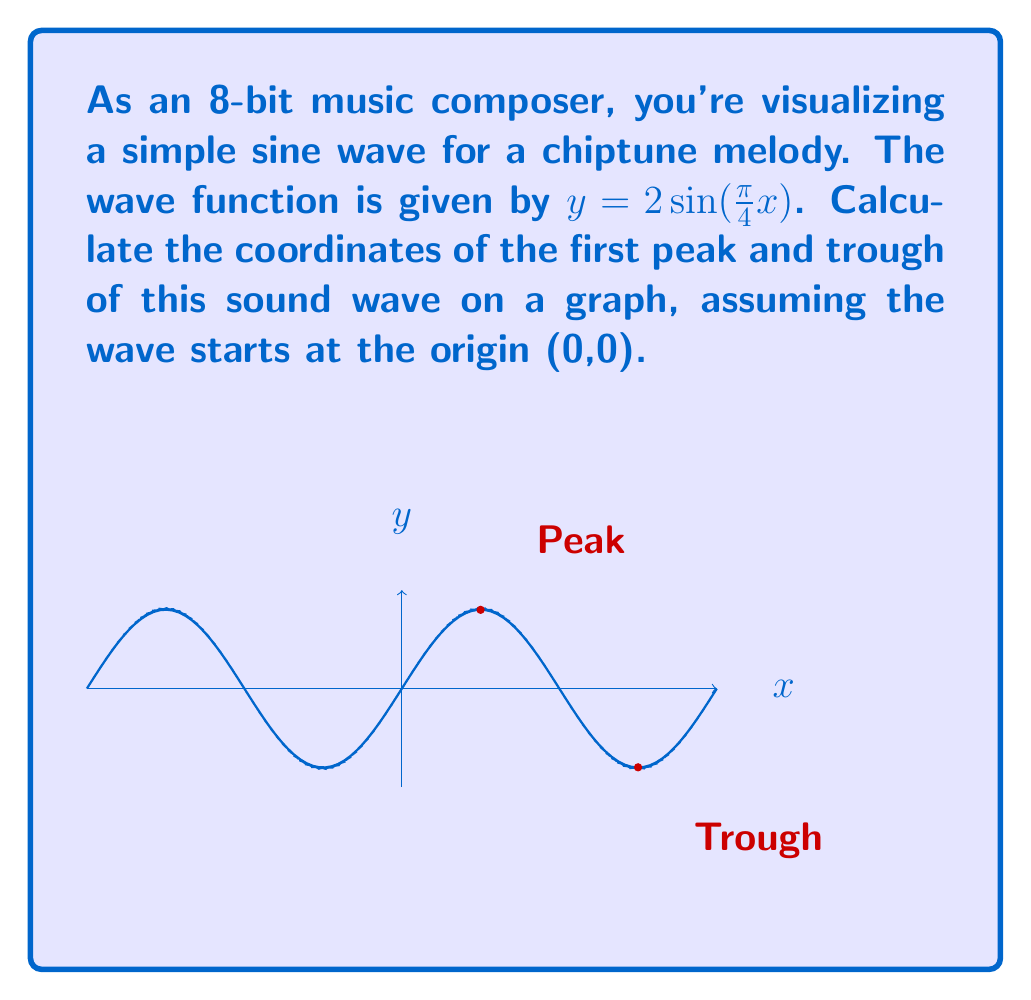Can you answer this question? Let's approach this step-by-step:

1) The general form of a sine wave is $y = A\sin(Bx)$, where $A$ is the amplitude and $B$ is related to the period.

2) In our case, $y = 2\sin(\frac{\pi}{4}x)$, so $A = 2$ and $B = \frac{\pi}{4}$.

3) The period of a sine wave is given by $\frac{2\pi}{B}$. Here, that's $\frac{2\pi}{\frac{\pi}{4}} = 8$.

4) The peak occurs at $\frac{1}{4}$ of the period, and the trough at $\frac{3}{4}$ of the period.

5) For the peak:
   x-coordinate: $\frac{1}{4} * 8 = 2$
   y-coordinate: $2\sin(\frac{\pi}{4}*2) = 2\sin(\frac{\pi}{2}) = 2$

6) For the trough:
   x-coordinate: $\frac{3}{4} * 8 = 6$
   y-coordinate: $2\sin(\frac{\pi}{4}*6) = 2\sin(\frac{3\pi}{2}) = -2$

Therefore, the coordinates of the first peak are (2,2), and the coordinates of the first trough are (6,-2).
Answer: Peak: (2,2), Trough: (6,-2) 